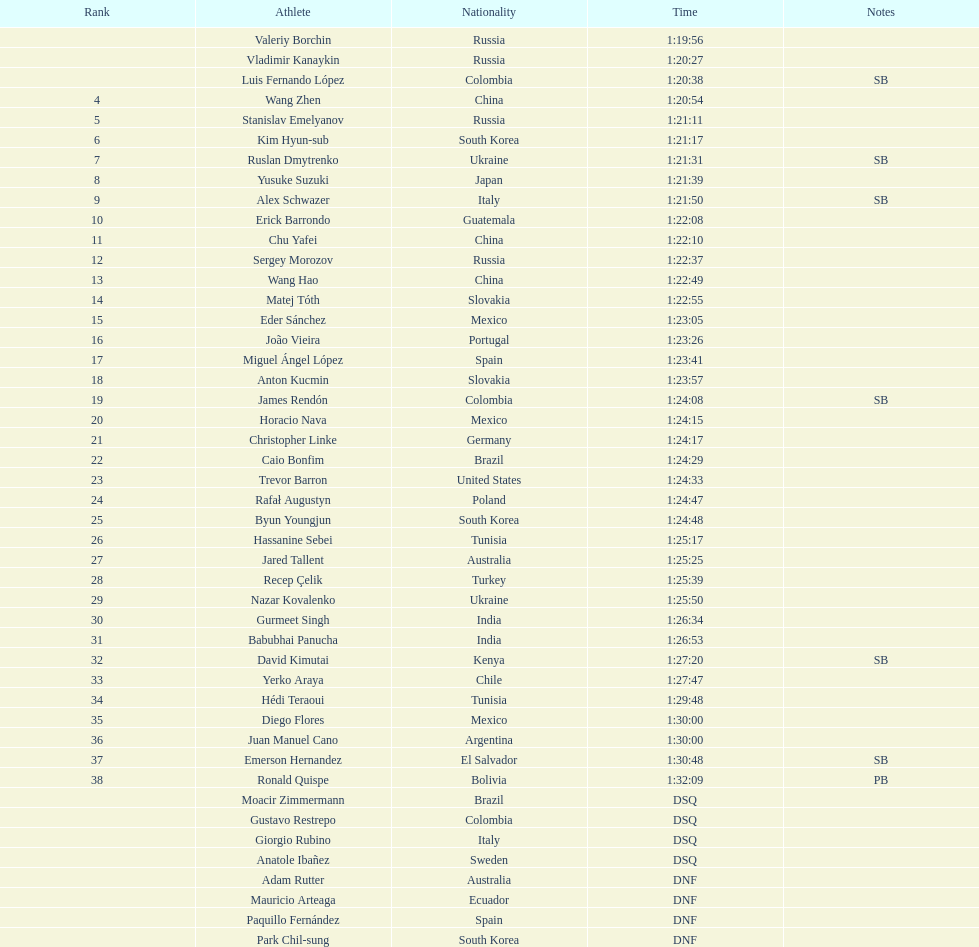Which competitor achieved the fastest time in the 20km? Valeriy Borchin. 